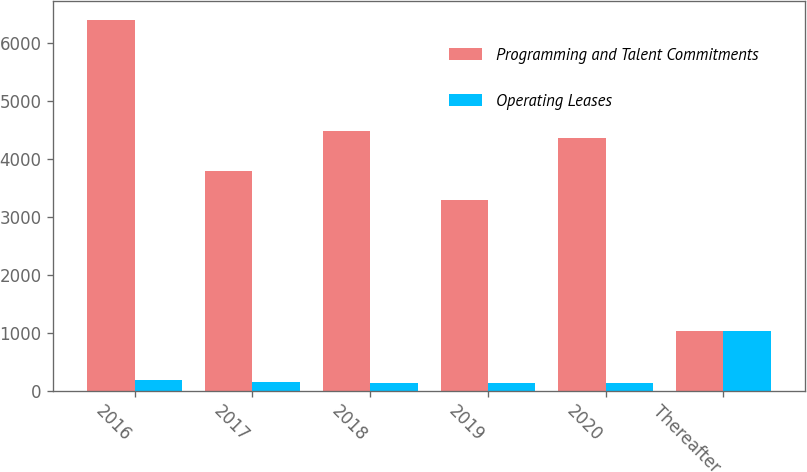<chart> <loc_0><loc_0><loc_500><loc_500><stacked_bar_chart><ecel><fcel>2016<fcel>2017<fcel>2018<fcel>2019<fcel>2020<fcel>Thereafter<nl><fcel>Programming and Talent Commitments<fcel>6391<fcel>3783<fcel>4470<fcel>3280<fcel>4357<fcel>1018<nl><fcel>Operating Leases<fcel>177<fcel>150<fcel>133<fcel>126<fcel>122<fcel>1018<nl></chart> 